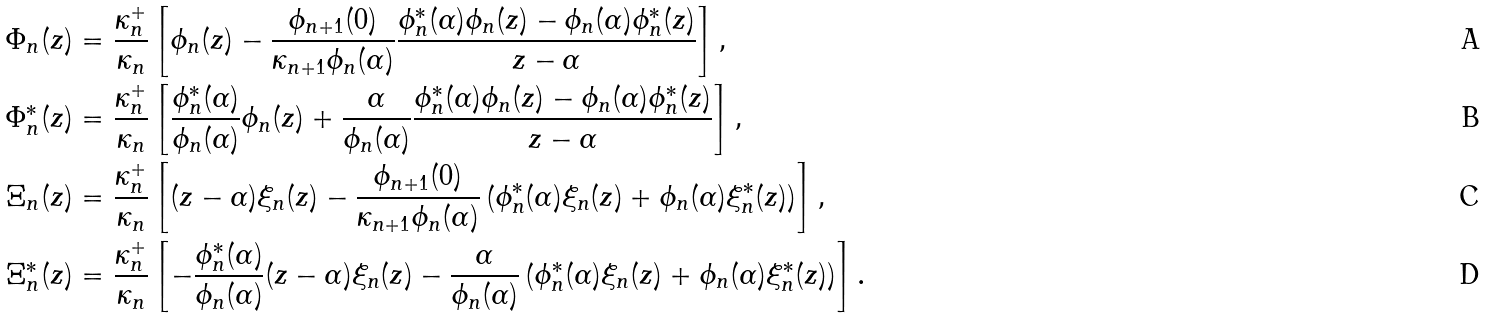Convert formula to latex. <formula><loc_0><loc_0><loc_500><loc_500>\Phi _ { n } ( z ) & = \frac { \kappa ^ { + } _ { n } } { \kappa _ { n } } \left [ \phi _ { n } ( z ) - \frac { \phi _ { n + 1 } ( 0 ) } { \kappa _ { n + 1 } \phi _ { n } ( \alpha ) } \frac { \phi ^ { * } _ { n } ( \alpha ) \phi _ { n } ( z ) - \phi _ { n } ( \alpha ) \phi ^ { * } _ { n } ( z ) } { z - \alpha } \right ] , \\ \Phi ^ { * } _ { n } ( z ) & = \frac { \kappa ^ { + } _ { n } } { \kappa _ { n } } \left [ \frac { \phi ^ { * } _ { n } ( \alpha ) } { \phi _ { n } ( \alpha ) } \phi _ { n } ( z ) + \frac { \alpha } { \phi _ { n } ( \alpha ) } \frac { \phi ^ { * } _ { n } ( \alpha ) \phi _ { n } ( z ) - \phi _ { n } ( \alpha ) \phi ^ { * } _ { n } ( z ) } { z - \alpha } \right ] , \\ \Xi _ { n } ( z ) & = \frac { \kappa ^ { + } _ { n } } { \kappa _ { n } } \left [ ( z - \alpha ) \xi _ { n } ( z ) - \frac { \phi _ { n + 1 } ( 0 ) } { \kappa _ { n + 1 } \phi _ { n } ( \alpha ) } \left ( \phi ^ { * } _ { n } ( \alpha ) \xi _ { n } ( z ) + \phi _ { n } ( \alpha ) \xi ^ { * } _ { n } ( z ) \right ) \right ] , \\ \Xi ^ { * } _ { n } ( z ) & = \frac { \kappa ^ { + } _ { n } } { \kappa _ { n } } \left [ - \frac { \phi ^ { * } _ { n } ( \alpha ) } { \phi _ { n } ( \alpha ) } ( z - \alpha ) \xi _ { n } ( z ) - \frac { \alpha } { \phi _ { n } ( \alpha ) } \left ( \phi ^ { * } _ { n } ( \alpha ) \xi _ { n } ( z ) + \phi _ { n } ( \alpha ) \xi ^ { * } _ { n } ( z ) \right ) \right ] .</formula> 